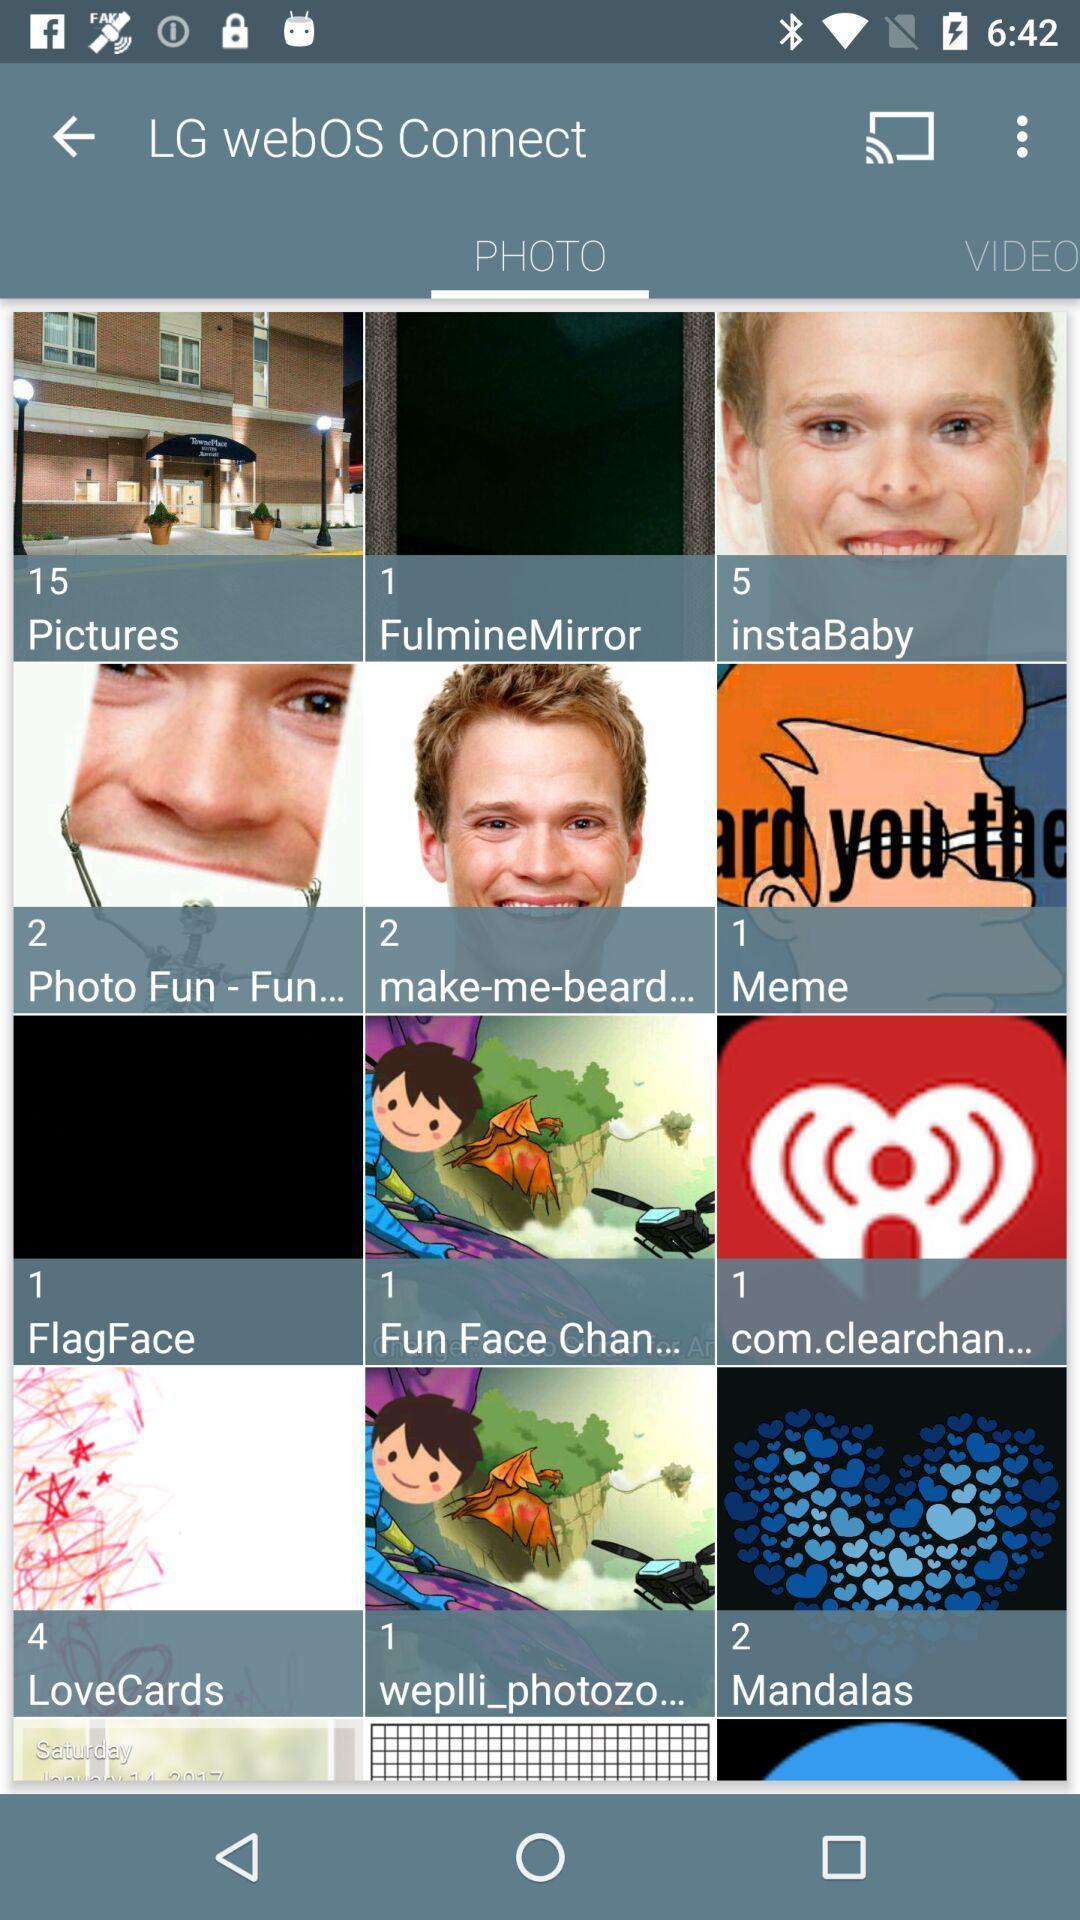What can you discern from this picture? Page showing gallery. 